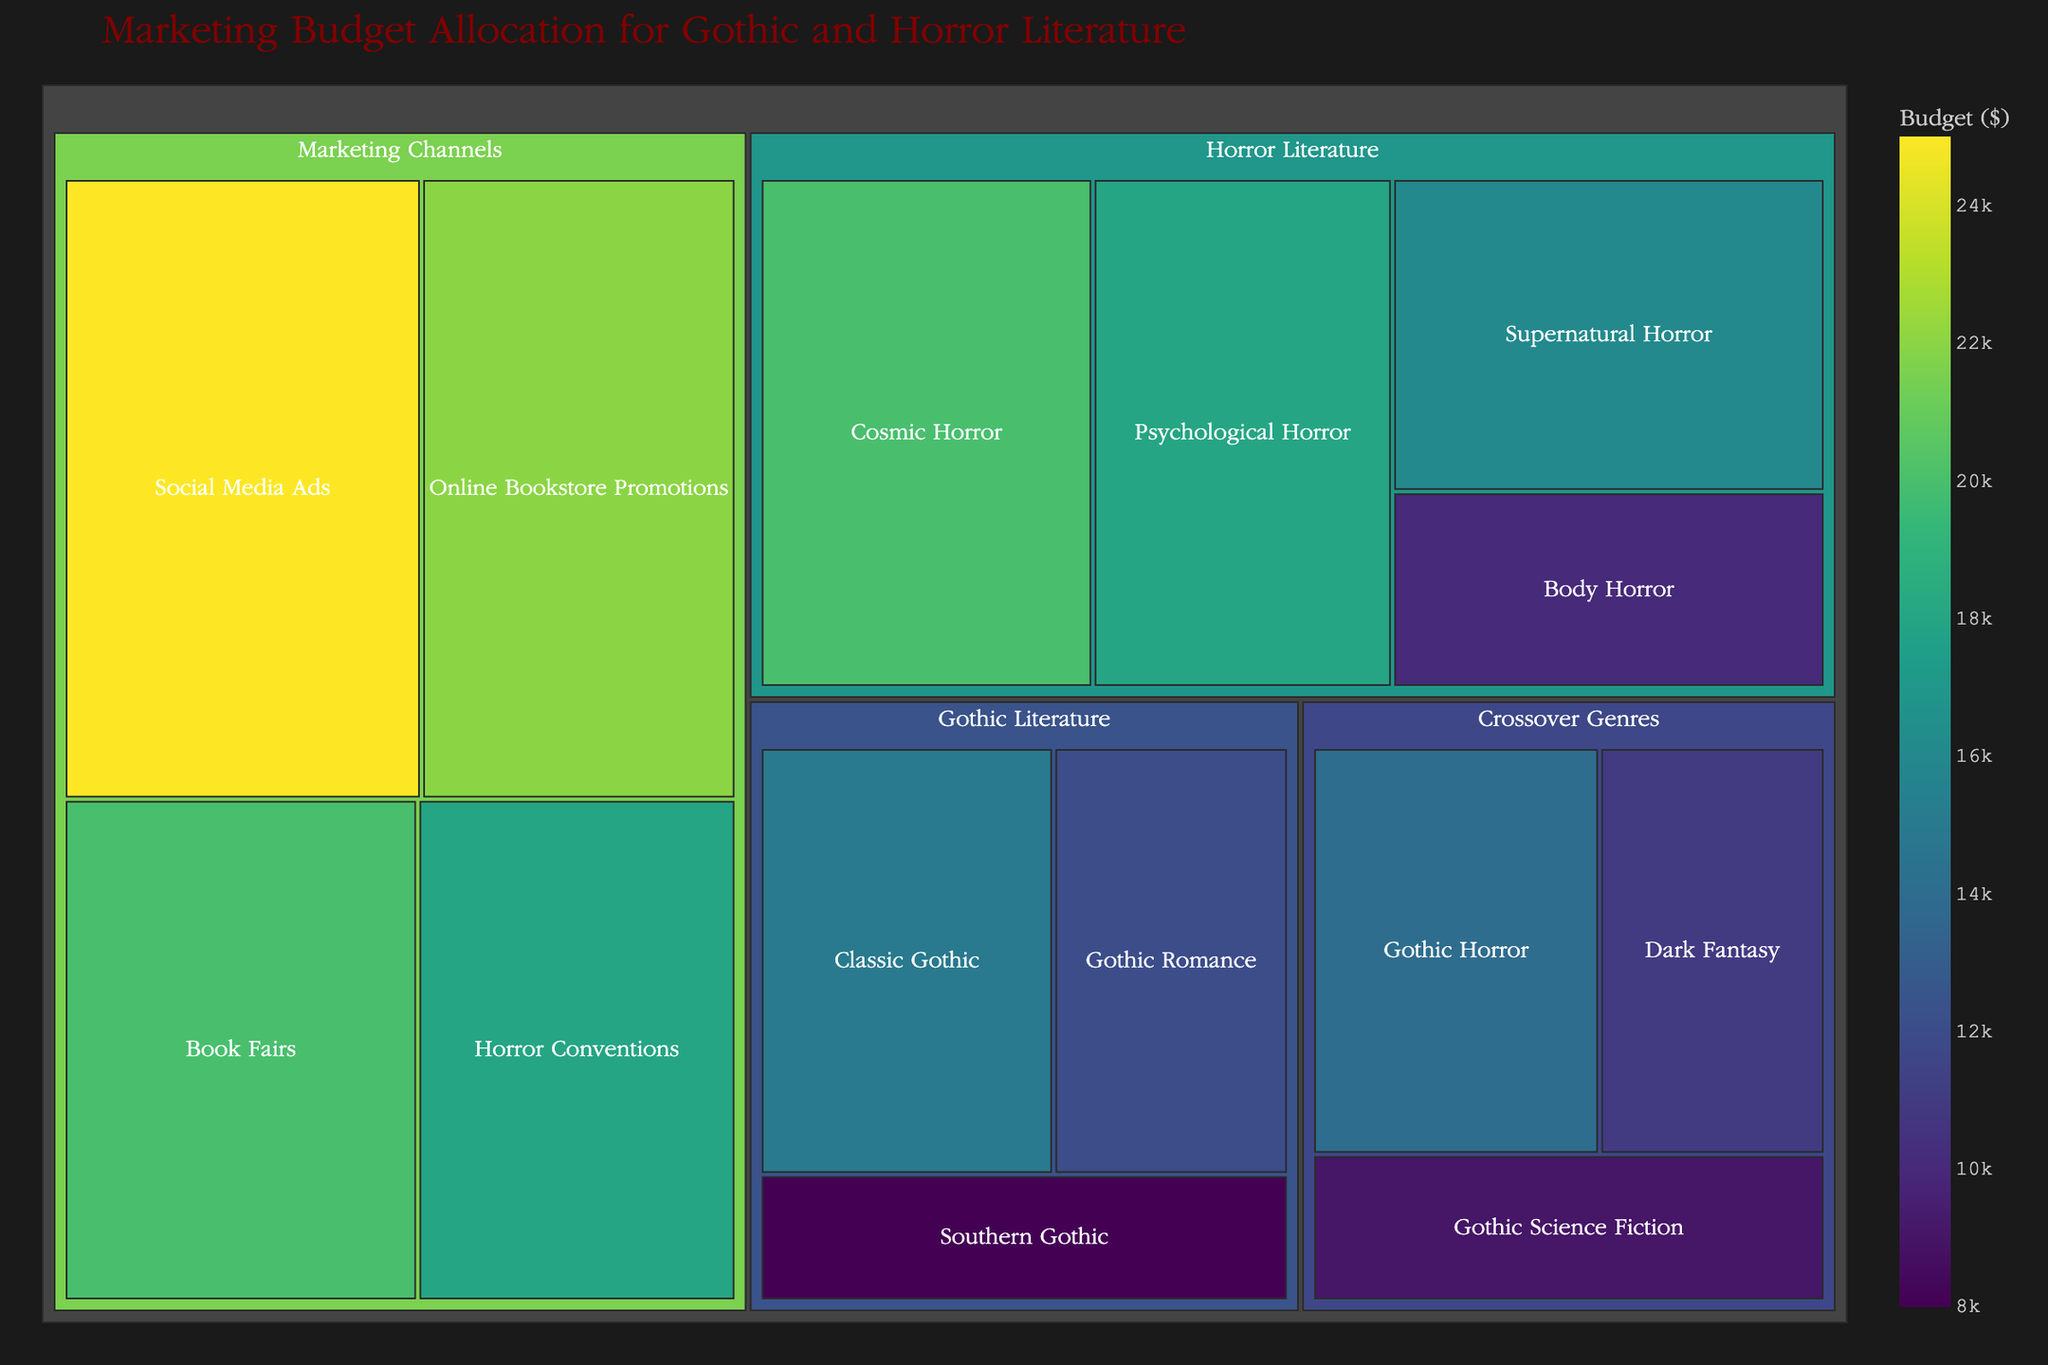What is the title of the treemap? The title is usually displayed at the top of the treemap and should be easily visible.
Answer: "Marketing Budget Allocation for Gothic and Horror Literature" Which category has the highest budget allocation? Check the category with the largest square and the highest value sum.
Answer: Marketing Channels How much budget is allocated to Supernatural Horror? Locate the section labeled "Supernatural Horror" within the Horror Literature category and read the budget value.
Answer: 16000 Which subcategory in Gothic Literature received the lowest budget? Compare the budget values within the Gothic Literature category and identify the smallest one.
Answer: Southern Gothic What is the total budget allocated for Horror Literature? Add up the budget values of all subcategories under Horror Literature.
Answer: 64000 Compare the budget allocation for Online Bookstore Promotions and Book Fairs. Which one is higher? Locate the sections labeled "Online Bookstore Promotions" and "Book Fairs" and compare their budget values.
Answer: Online Bookstore Promotions What is the cumulative budget for all subcategories under Crossover Genres? Sum the budget values for Gothic Horror, Dark Fantasy, and Gothic Science Fiction.
Answer: 34000 How does the budget for Classic Gothic compare to that of Gothic Romance? Identify the budget values for Classic Gothic and Gothic Romance and determine the difference.
Answer: Classic Gothic Which horror subcategory received the least funding? Identify the subcategory within Horror Literature with the smallest budget.
Answer: Body Horror What percentage of the total marketing budget is allocated to Psychological Horror? Divide the Psychological Horror budget by the total budget and multiply by 100. The total budget is the sum of all budget values.
Answer: 8.2% Which marketing channel received the largest allocation? Identify the marketing channel with the largest square within the Marketing Channels category.
Answer: Social Media Ads 